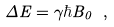<formula> <loc_0><loc_0><loc_500><loc_500>\Delta { E } = \gamma \hbar { B } _ { 0 } \ ,</formula> 